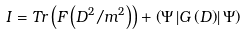<formula> <loc_0><loc_0><loc_500><loc_500>I = T r \left ( F \left ( D ^ { 2 } / m ^ { 2 } \right ) \right ) + \left ( \Psi \left | G \left ( D \right ) \right | \Psi \right )</formula> 